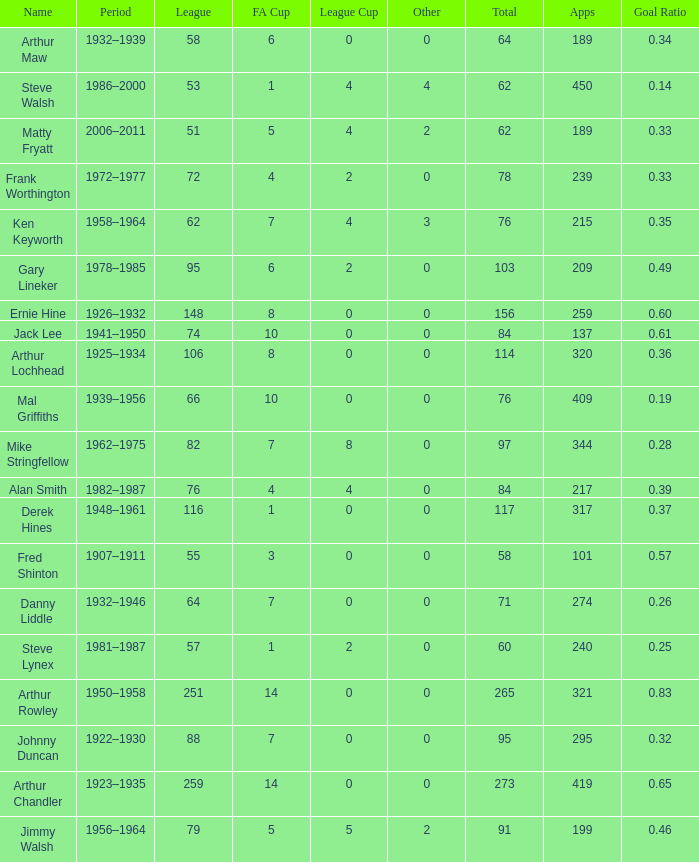What's the Highest Goal Ratio with a League of 88 and an FA Cup less than 7? None. 